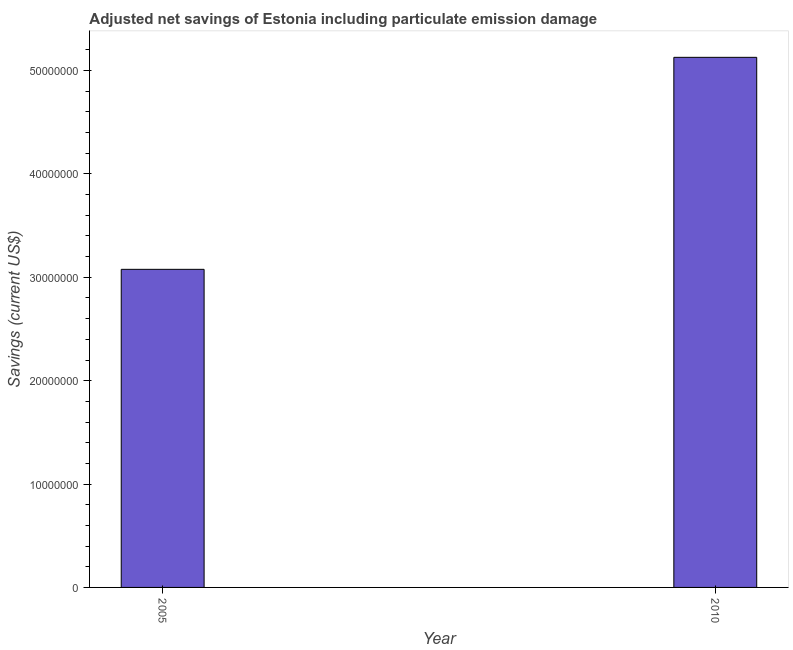Does the graph contain grids?
Provide a short and direct response. No. What is the title of the graph?
Offer a very short reply. Adjusted net savings of Estonia including particulate emission damage. What is the label or title of the X-axis?
Keep it short and to the point. Year. What is the label or title of the Y-axis?
Provide a short and direct response. Savings (current US$). What is the adjusted net savings in 2005?
Your response must be concise. 3.08e+07. Across all years, what is the maximum adjusted net savings?
Offer a very short reply. 5.13e+07. Across all years, what is the minimum adjusted net savings?
Offer a terse response. 3.08e+07. What is the sum of the adjusted net savings?
Provide a short and direct response. 8.20e+07. What is the difference between the adjusted net savings in 2005 and 2010?
Provide a succinct answer. -2.05e+07. What is the average adjusted net savings per year?
Offer a terse response. 4.10e+07. What is the median adjusted net savings?
Ensure brevity in your answer.  4.10e+07. Is the adjusted net savings in 2005 less than that in 2010?
Your response must be concise. Yes. How many bars are there?
Provide a short and direct response. 2. Are all the bars in the graph horizontal?
Offer a very short reply. No. What is the Savings (current US$) of 2005?
Provide a short and direct response. 3.08e+07. What is the Savings (current US$) in 2010?
Provide a short and direct response. 5.13e+07. What is the difference between the Savings (current US$) in 2005 and 2010?
Ensure brevity in your answer.  -2.05e+07. What is the ratio of the Savings (current US$) in 2005 to that in 2010?
Provide a short and direct response. 0.6. 